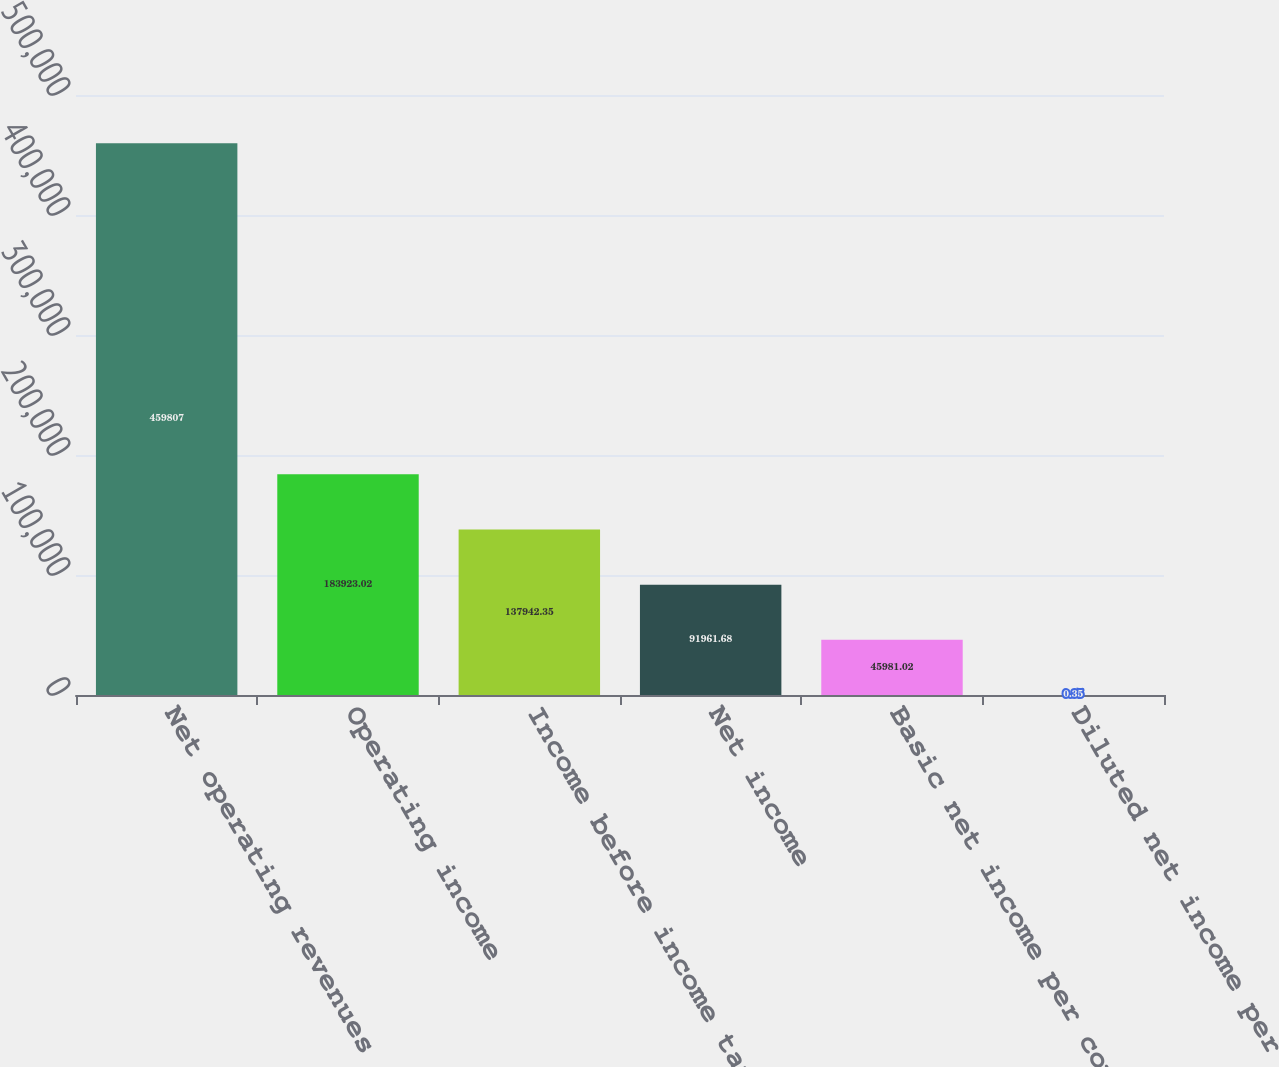<chart> <loc_0><loc_0><loc_500><loc_500><bar_chart><fcel>Net operating revenues<fcel>Operating income<fcel>Income before income taxes<fcel>Net income<fcel>Basic net income per common<fcel>Diluted net income per common<nl><fcel>459807<fcel>183923<fcel>137942<fcel>91961.7<fcel>45981<fcel>0.35<nl></chart> 